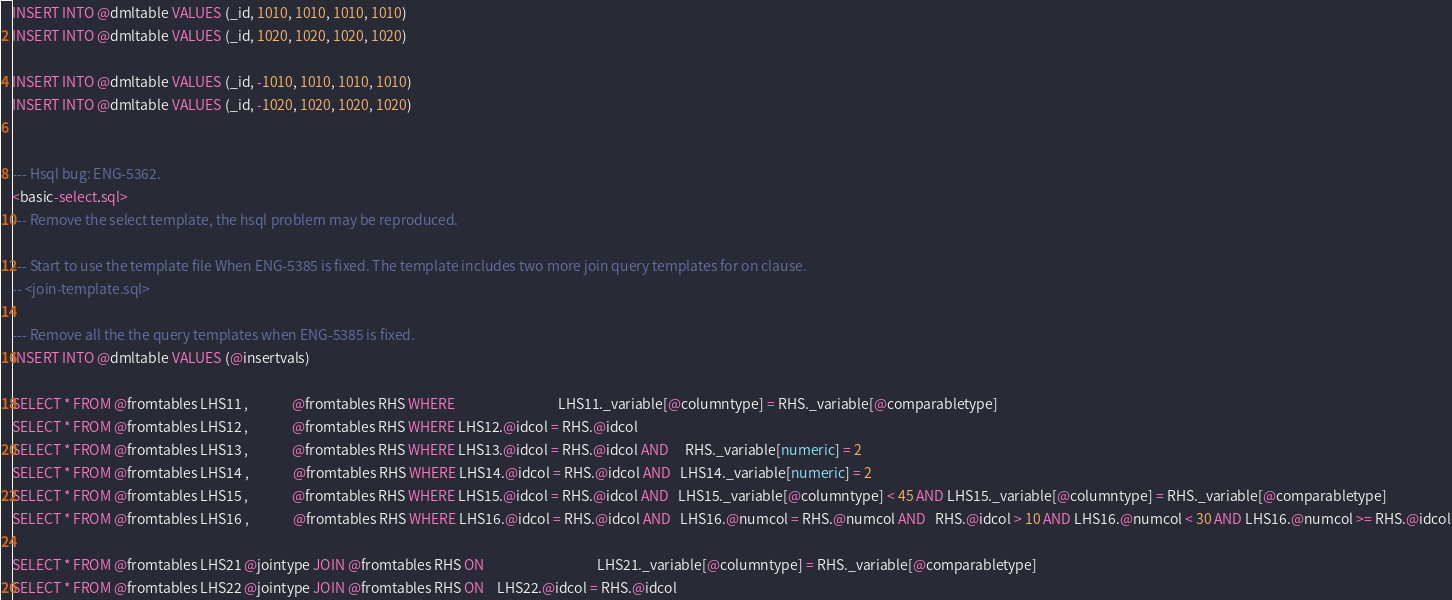<code> <loc_0><loc_0><loc_500><loc_500><_SQL_>INSERT INTO @dmltable VALUES (_id, 1010, 1010, 1010, 1010)
INSERT INTO @dmltable VALUES (_id, 1020, 1020, 1020, 1020)

INSERT INTO @dmltable VALUES (_id, -1010, 1010, 1010, 1010)
INSERT INTO @dmltable VALUES (_id, -1020, 1020, 1020, 1020)


--- Hsql bug: ENG-5362.
<basic-select.sql>
--- Remove the select template, the hsql problem may be reproduced.

--- Start to use the template file When ENG-5385 is fixed. The template includes two more join query templates for on clause. 
-- <join-template.sql>

--- Remove all the the query templates when ENG-5385 is fixed.
INSERT INTO @dmltable VALUES (@insertvals)

SELECT * FROM @fromtables LHS11 ,              @fromtables RHS WHERE                                 LHS11._variable[@columntype] = RHS._variable[@comparabletype]
SELECT * FROM @fromtables LHS12 ,              @fromtables RHS WHERE LHS12.@idcol = RHS.@idcol
SELECT * FROM @fromtables LHS13 ,              @fromtables RHS WHERE LHS13.@idcol = RHS.@idcol AND     RHS._variable[numeric] = 2 
SELECT * FROM @fromtables LHS14 ,              @fromtables RHS WHERE LHS14.@idcol = RHS.@idcol AND   LHS14._variable[numeric] = 2
SELECT * FROM @fromtables LHS15 ,              @fromtables RHS WHERE LHS15.@idcol = RHS.@idcol AND   LHS15._variable[@columntype] < 45 AND LHS15._variable[@columntype] = RHS._variable[@comparabletype]
SELECT * FROM @fromtables LHS16 ,              @fromtables RHS WHERE LHS16.@idcol = RHS.@idcol AND   LHS16.@numcol = RHS.@numcol AND   RHS.@idcol > 10 AND LHS16.@numcol < 30 AND LHS16.@numcol >= RHS.@idcol

SELECT * FROM @fromtables LHS21 @jointype JOIN @fromtables RHS ON                                    LHS21._variable[@columntype] = RHS._variable[@comparabletype]
SELECT * FROM @fromtables LHS22 @jointype JOIN @fromtables RHS ON    LHS22.@idcol = RHS.@idcol
</code> 